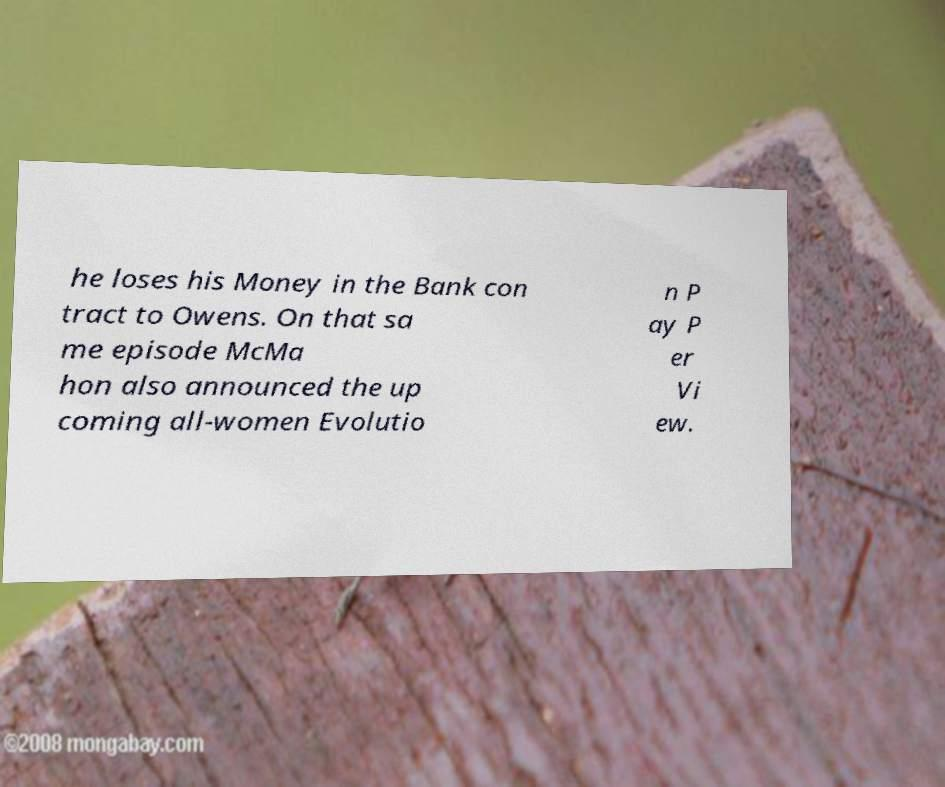Could you assist in decoding the text presented in this image and type it out clearly? he loses his Money in the Bank con tract to Owens. On that sa me episode McMa hon also announced the up coming all-women Evolutio n P ay P er Vi ew. 